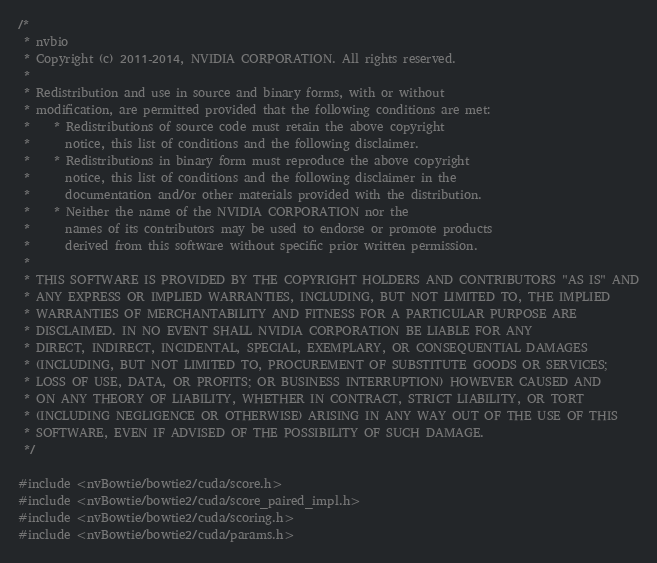<code> <loc_0><loc_0><loc_500><loc_500><_Cuda_>/*
 * nvbio
 * Copyright (c) 2011-2014, NVIDIA CORPORATION. All rights reserved.
 * 
 * Redistribution and use in source and binary forms, with or without
 * modification, are permitted provided that the following conditions are met:
 *    * Redistributions of source code must retain the above copyright
 *      notice, this list of conditions and the following disclaimer.
 *    * Redistributions in binary form must reproduce the above copyright
 *      notice, this list of conditions and the following disclaimer in the
 *      documentation and/or other materials provided with the distribution.
 *    * Neither the name of the NVIDIA CORPORATION nor the
 *      names of its contributors may be used to endorse or promote products
 *      derived from this software without specific prior written permission.
 * 
 * THIS SOFTWARE IS PROVIDED BY THE COPYRIGHT HOLDERS AND CONTRIBUTORS "AS IS" AND
 * ANY EXPRESS OR IMPLIED WARRANTIES, INCLUDING, BUT NOT LIMITED TO, THE IMPLIED
 * WARRANTIES OF MERCHANTABILITY AND FITNESS FOR A PARTICULAR PURPOSE ARE
 * DISCLAIMED. IN NO EVENT SHALL NVIDIA CORPORATION BE LIABLE FOR ANY
 * DIRECT, INDIRECT, INCIDENTAL, SPECIAL, EXEMPLARY, OR CONSEQUENTIAL DAMAGES
 * (INCLUDING, BUT NOT LIMITED TO, PROCUREMENT OF SUBSTITUTE GOODS OR SERVICES;
 * LOSS OF USE, DATA, OR PROFITS; OR BUSINESS INTERRUPTION) HOWEVER CAUSED AND
 * ON ANY THEORY OF LIABILITY, WHETHER IN CONTRACT, STRICT LIABILITY, OR TORT
 * (INCLUDING NEGLIGENCE OR OTHERWISE) ARISING IN ANY WAY OUT OF THE USE OF THIS
 * SOFTWARE, EVEN IF ADVISED OF THE POSSIBILITY OF SUCH DAMAGE.
 */

#include <nvBowtie/bowtie2/cuda/score.h>
#include <nvBowtie/bowtie2/cuda/score_paired_impl.h>
#include <nvBowtie/bowtie2/cuda/scoring.h>
#include <nvBowtie/bowtie2/cuda/params.h></code> 